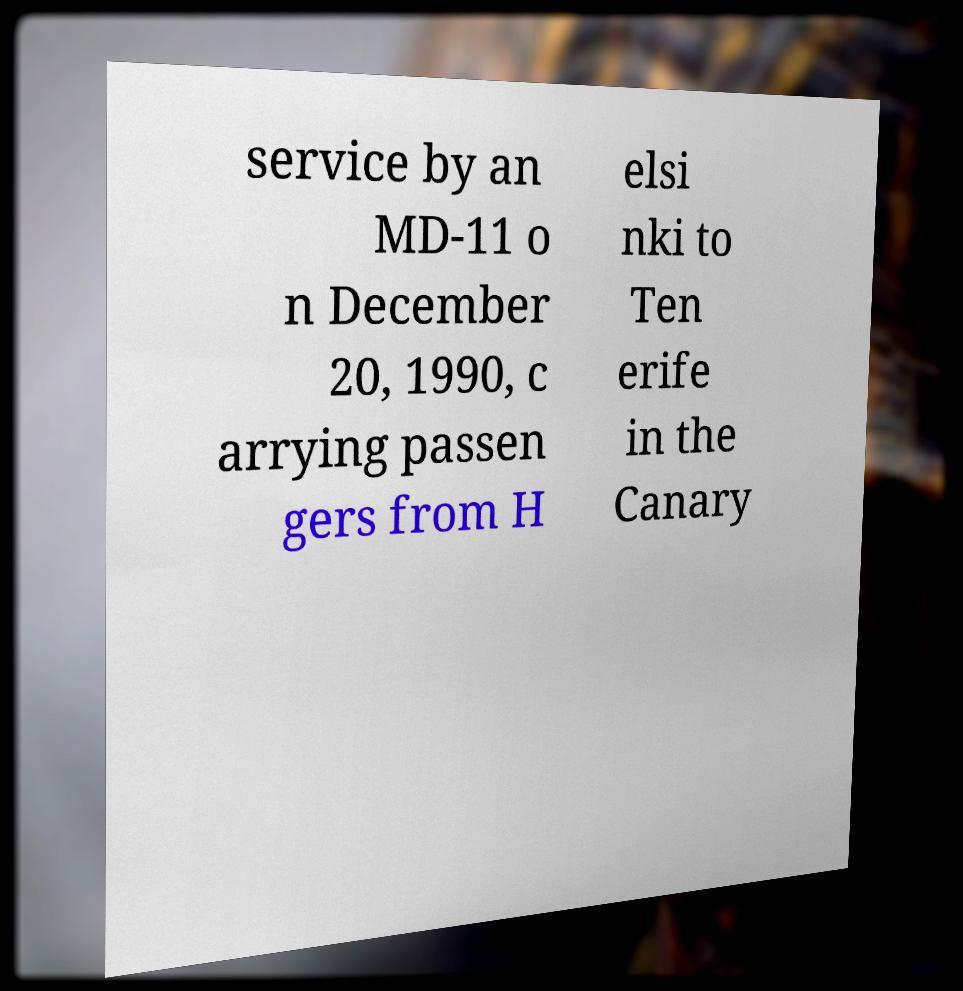Could you extract and type out the text from this image? service by an MD-11 o n December 20, 1990, c arrying passen gers from H elsi nki to Ten erife in the Canary 